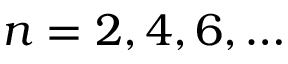<formula> <loc_0><loc_0><loc_500><loc_500>n = 2 , 4 , 6 , \dots</formula> 